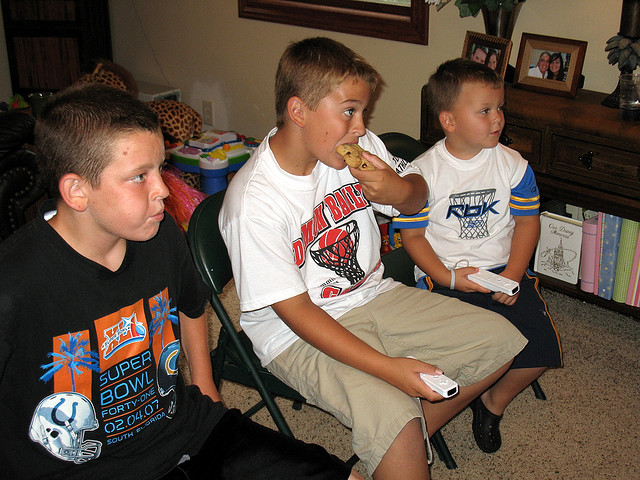Read and extract the text from this image. DMN BAIL RBK SUPER BOWL FORTY South 07 04 02 ONE 